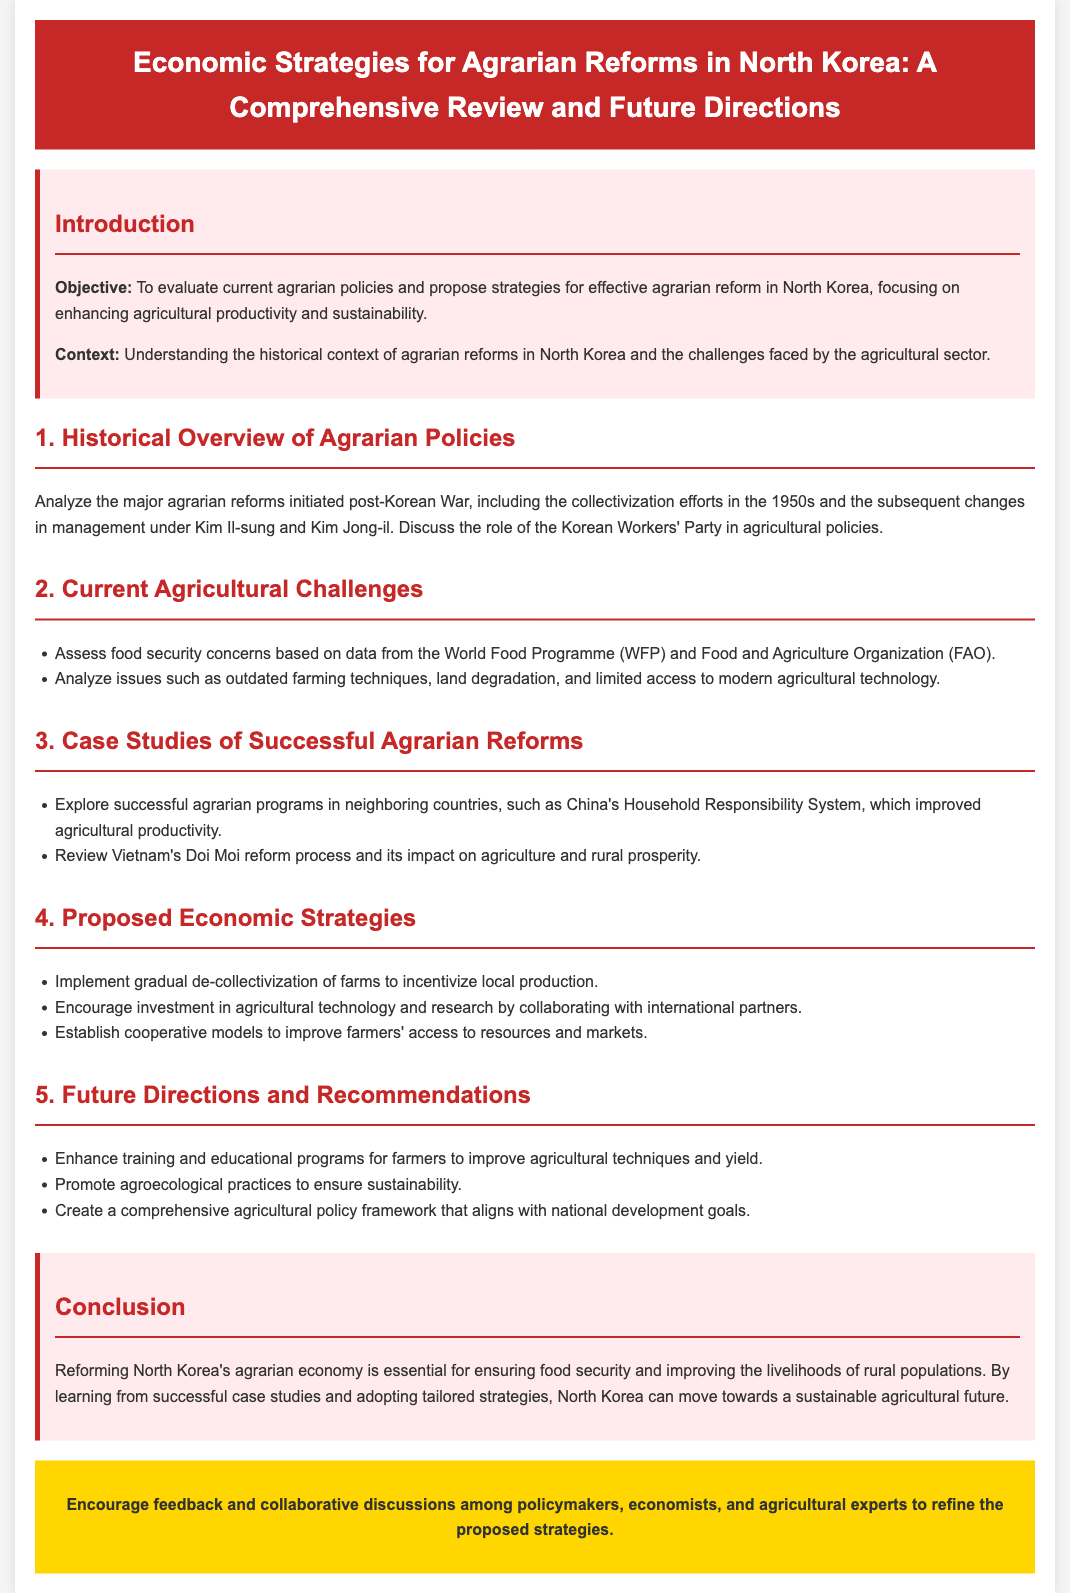What is the objective of the document? The objective is to evaluate current agrarian policies and propose strategies for effective agrarian reform in North Korea, focusing on enhancing agricultural productivity and sustainability.
Answer: To evaluate current agrarian policies and propose strategies for effective agrarian reform in North Korea, focusing on enhancing agricultural productivity and sustainability What major reforms are discussed in the historical overview? The document discusses collectivization efforts initiated post-Korean War in the 1950s and subsequent changes in management under Kim Il-sung and Kim Jong-il.
Answer: Collectivization efforts Which international organizations are mentioned regarding food security? The document mentions the World Food Programme (WFP) and the Food and Agriculture Organization (FAO) in the context of food security concerns.
Answer: World Food Programme (WFP) and Food and Agriculture Organization (FAO) What is one proposed economic strategy for agricultural improvement? The document proposes the implementation of gradual de-collectivization of farms to incentivize local production as a strategy for agricultural improvement.
Answer: Gradual de-collectivization of farms Which country's program is cited as a successful example of agrarian reform? The document cites China's Household Responsibility System as a successful agrarian program that improved agricultural productivity.
Answer: China's Household Responsibility System What is a recommended future direction related to farmer education? The document recommends enhancing training and educational programs for farmers to improve agricultural techniques and yield.
Answer: Enhancing training and educational programs 